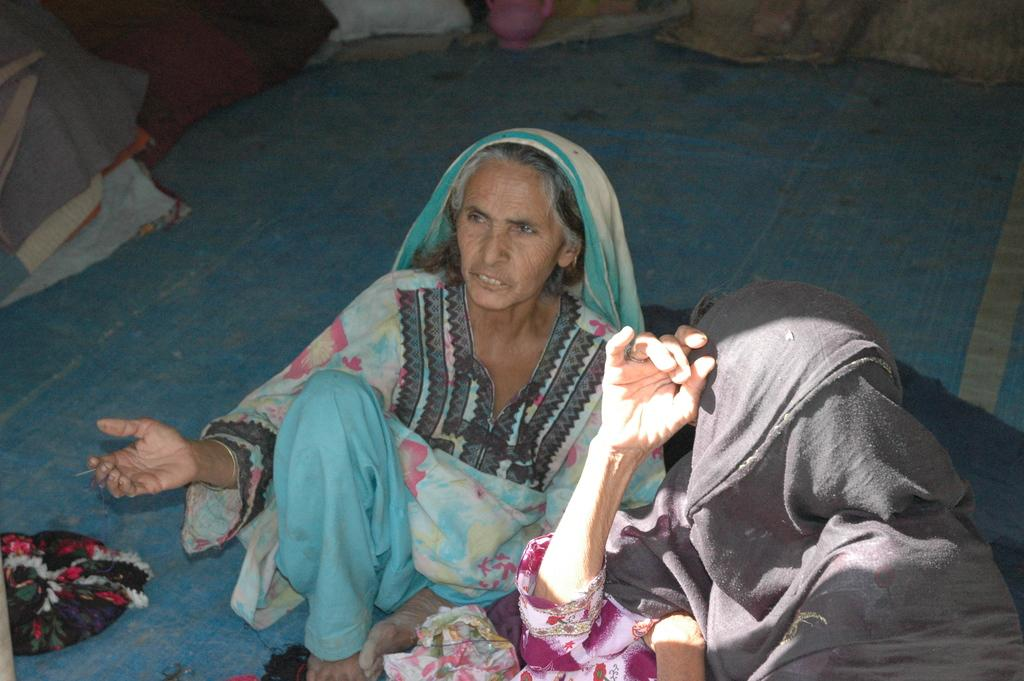Who is present in the image? There is a woman and a person in the image. What are the woman and the person doing in the image? Both the woman and the person are sitting. Can you describe the background of the image? There are objects visible in the background of the image. What type of fan is visible in the image? There is no fan present in the image. Can you describe the wing of the bird in the image? There is no bird or wing present in the image. 